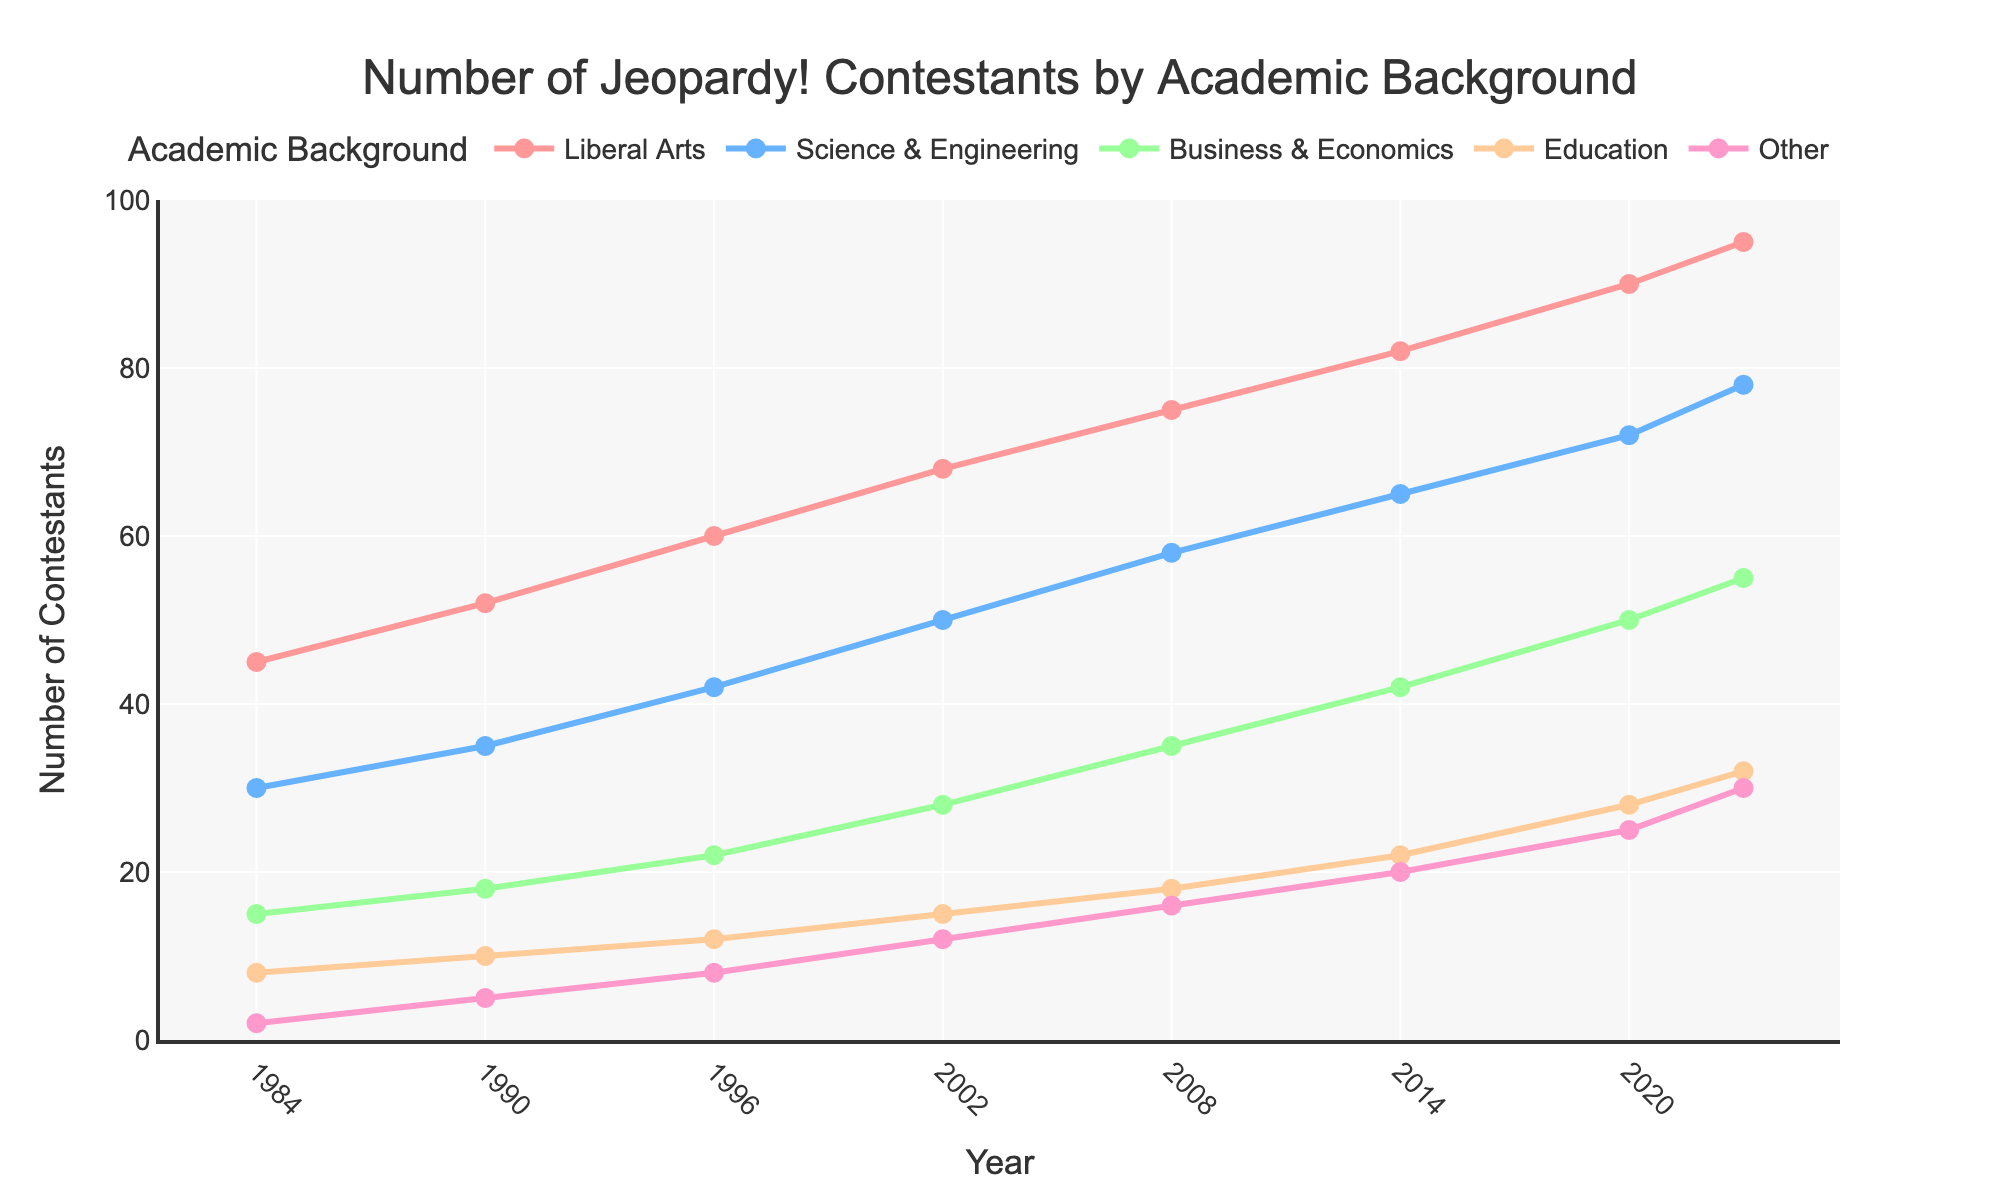What academic background had the highest number of contestants in 2023? By looking at the lines on the graph, we can see that the "Liberal Arts" line reaches the highest point in 2023 compared to other academic backgrounds.
Answer: Liberal Arts Which academic background showed the most consistent increase in contestants from 1984 to 2023? By observing the slope and steadiness of each line, the "Liberal Arts" line consistently increases without any declines throughout the years.
Answer: Liberal Arts In which years did contestants from "Science & Engineering" outnumber those from "Business & Economics"? By comparing the heights of the "Science & Engineering" and "Business & Economics" lines, we see that "Science & Engineering" had more contestants in every given year from 1984 to 2023.
Answer: All years What is the sum of contestants from "Education" in 1984 and "Business & Economics" in 2023? To find the sum, we add the number of "Education" contestants in 1984 (8) to the number of "Business & Economics" contestants in 2023 (55), resulting in 8 + 55 = 63.
Answer: 63 Which academic background had the smallest number of contestants in 1996? By reviewing the line at the year 1996, the "Other" category has the lowest point with 8 contestants.
Answer: Other How much did the number of "Science & Engineering" contestants increase from 2002 to 2008? The number of "Science & Engineering" contestants in 2002 is 50, and in 2008 it is 58. The increase is calculated as 58 - 50 = 8.
Answer: 8 Has the number of contestants with a "Business & Economics" background ever been higher than those with an "Education" background? By comparing the lines for "Business & Economics" and "Education" at all points in time, "Business & Economics" always has higher counts.
Answer: Yes What's the average number of "Liberal Arts" contestants from 1984 to 2023? Summing the numbers for "Liberal Arts" across all years (45+52+60+68+75+82+90+95 = 567) and dividing by the number of years (8), the average is 567 / 8 = 70.875.
Answer: 70.875 What year did "Other" contestants first exceed 10? Checking the data points for "Other," the number first exceeds 10 in the year 2002 with 12 contestants.
Answer: 2002 By what factor did the number of "Liberal Arts" contestants grow from 1984 to 2023? The number of "Liberal Arts" contestants in 1984 is 45, and in 2023 it is 95. The factor is calculated as 95 / 45 ≈ 2.11.
Answer: 2.11 